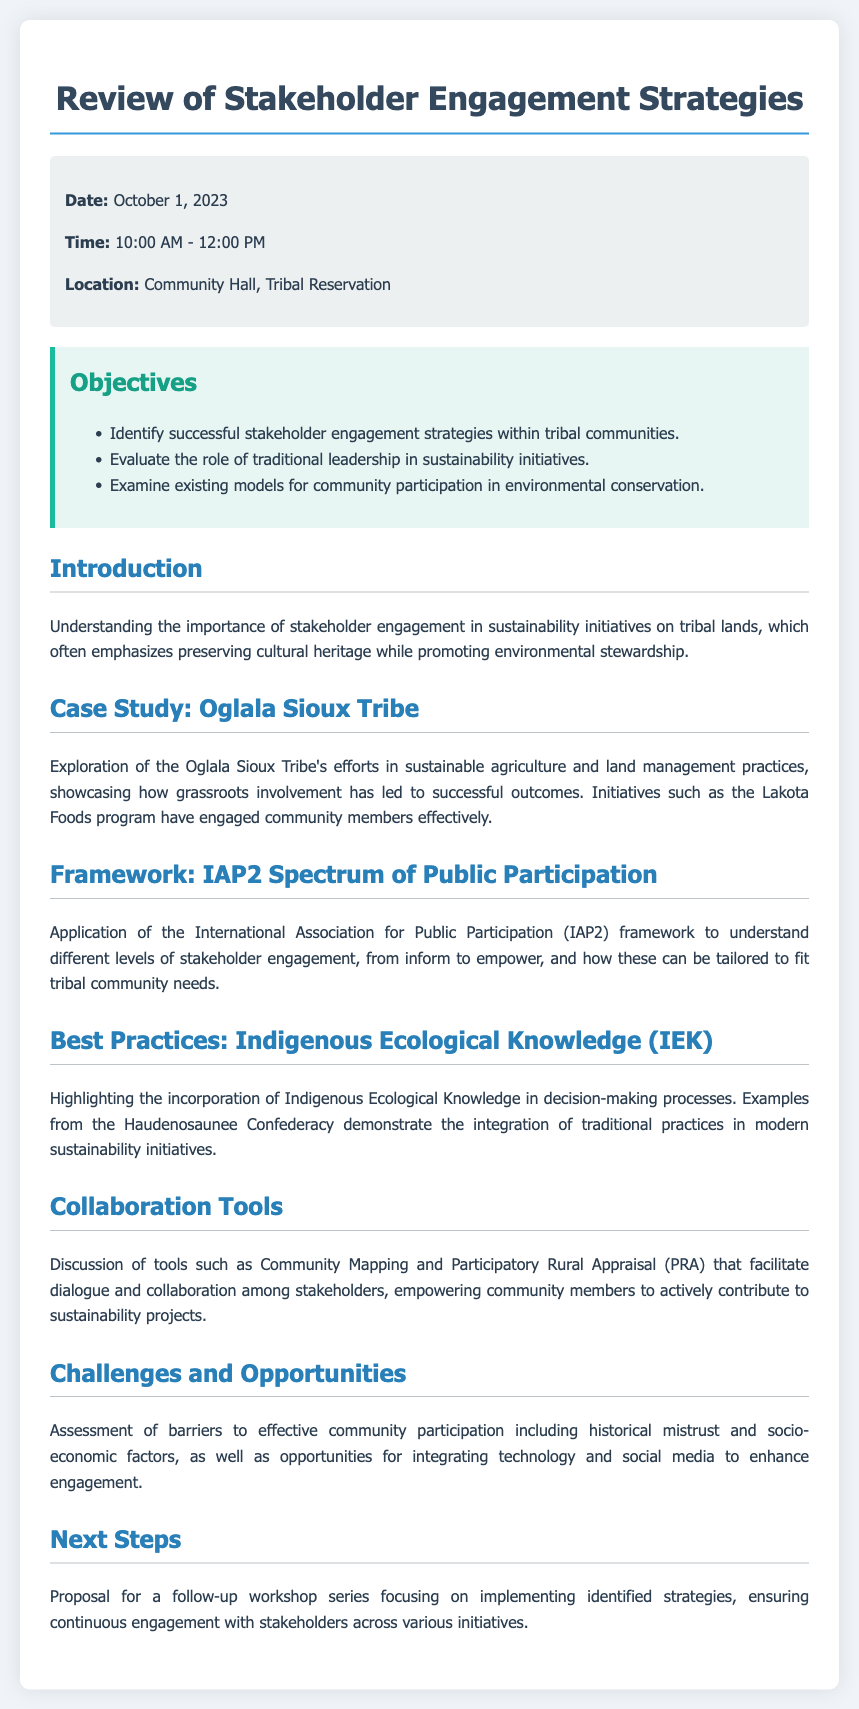What is the date of the meeting? The meeting is scheduled for October 1, 2023, as listed in the header information.
Answer: October 1, 2023 What time does the event start? The event begins at 10:00 AM, according to the header information.
Answer: 10:00 AM Where is the location of the meeting? The location of the meeting is mentioned as Community Hall, Tribal Reservation in the header information.
Answer: Community Hall, Tribal Reservation Which case study is mentioned in the document? The document refers to the Oglala Sioux Tribe as a case study.
Answer: Oglala Sioux Tribe What framework is discussed in relation to stakeholder engagement? The IAP2 Spectrum of Public Participation framework is referenced to understand engagement levels.
Answer: IAP2 Spectrum of Public Participation What is one of the objectives outlined in the document? One objective is to evaluate the role of traditional leadership in sustainability initiatives.
Answer: Evaluate the role of traditional leadership What challenges are mentioned that affect community participation? The document highlights historical mistrust as one of the barriers to effective participation.
Answer: Historical mistrust What practice is highlighted that integrates traditional knowledge? The incorporation of Indigenous Ecological Knowledge (IEK) in decision-making processes is emphasized.
Answer: Indigenous Ecological Knowledge (IEK) What collaboration tool is discussed for stakeholder engagement? The document mentions Community Mapping as a tool for facilitating dialogue.
Answer: Community Mapping 